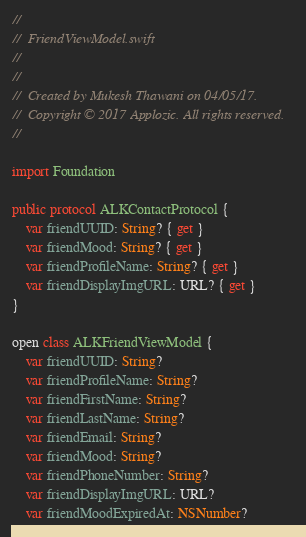Convert code to text. <code><loc_0><loc_0><loc_500><loc_500><_Swift_>//
//  FriendViewModel.swift
//
//
//  Created by Mukesh Thawani on 04/05/17.
//  Copyright © 2017 Applozic. All rights reserved.
//

import Foundation

public protocol ALKContactProtocol {
    var friendUUID: String? { get }
    var friendMood: String? { get }
    var friendProfileName: String? { get }
    var friendDisplayImgURL: URL? { get }
}

open class ALKFriendViewModel {
    var friendUUID: String?
    var friendProfileName: String?
    var friendFirstName: String?
    var friendLastName: String?
    var friendEmail: String?
    var friendMood: String?
    var friendPhoneNumber: String?
    var friendDisplayImgURL: URL?
    var friendMoodExpiredAt: NSNumber?</code> 